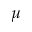Convert formula to latex. <formula><loc_0><loc_0><loc_500><loc_500>\mu</formula> 